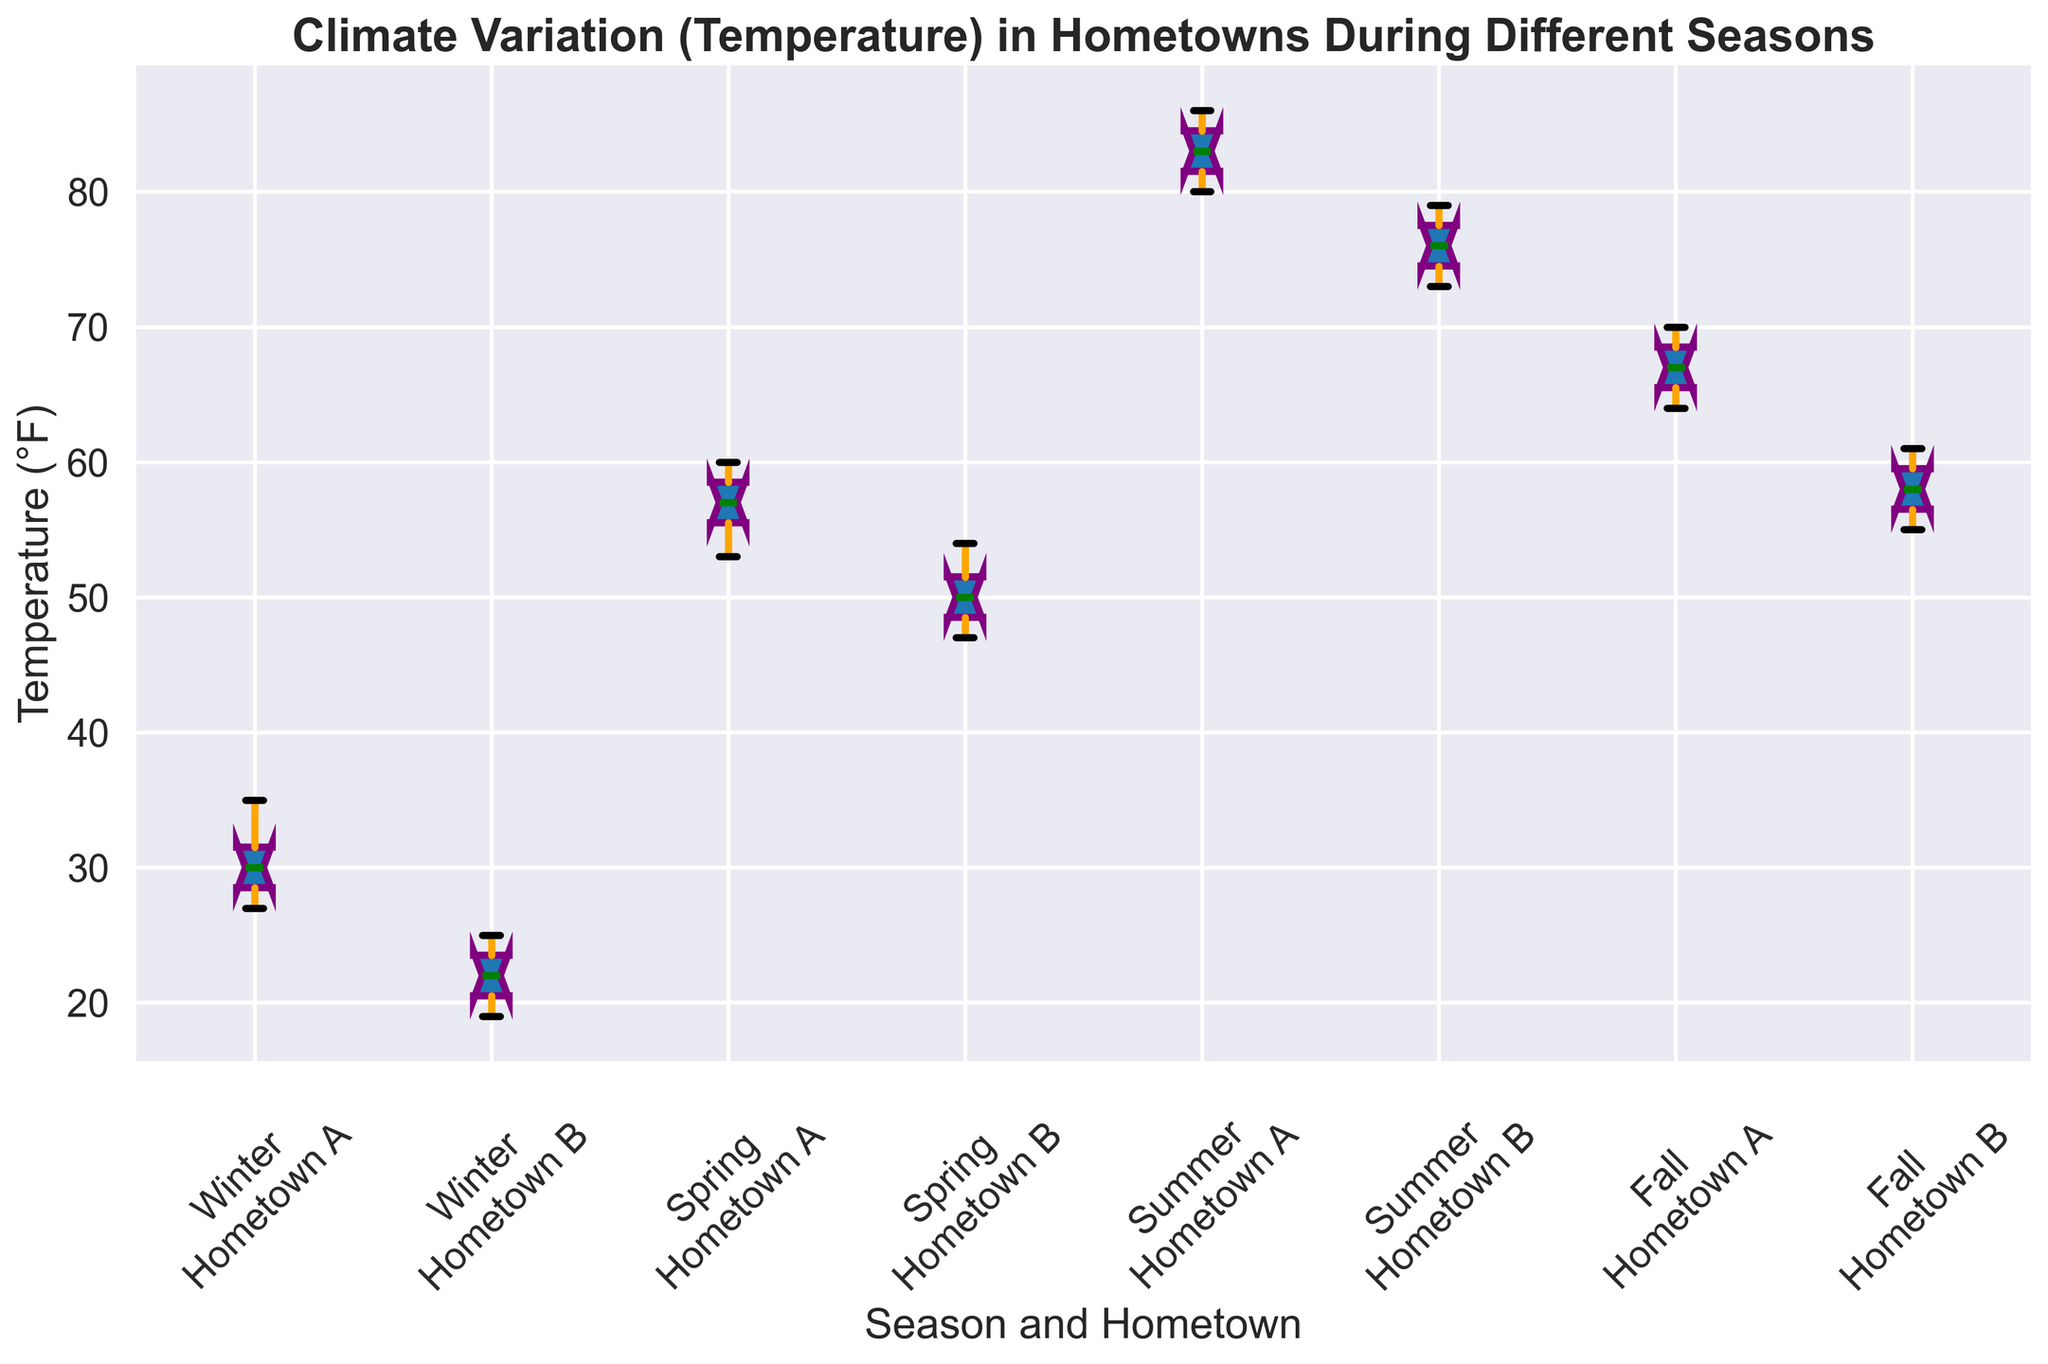What is the median temperature for Hometown A in Winter? Look at the box plot for Winter under Hometown A. The median is represented by the green line inside the box.
Answer: 30.5°F Which season shows the highest median temperature for Hometown B? Compare the median lines (green lines inside the boxes) for all the seasons under Hometown B. Identify which one is the highest.
Answer: Summer How does the temperature variation in Hometown A during Summer compare to Winter? Compare the length of the boxes (representing the interquartile range) for Summer and Winter under Hometown A to see which has larger variation, also consider the whiskers' length.
Answer: Summer has larger variation What is the interquartile range (IQR) for Hometown B in Fall? The IQR is the length of the box. Measure the distance on the y-axis between the bottom and top of the box for Fall under Hometown B.
Answer: 4°F In which season does Hometown B have the smallest temperature range? Look at the total length (box plus whiskers) for each season under Hometown B and find the smallest one.
Answer: Fall Is the median temperature higher in Spring or Summer for Hometown A? Compare the green lines inside the boxes for Spring and Summer under Hometown A to see which one is higher.
Answer: Summer How many degrees higher is the median temperature in Summer compared to Winter for Hometown A? Subtract the median temperature in Winter from the median temperature in Summer for Hometown A by looking at the green lines.
Answer: 52°F Which season has the greatest temperature variation for Hometown B? Look for the season with the largest spread (length of the box plus whiskers) under Hometown B to determine the greatest variation.
Answer: Summer Compare the temperature distributions between Hometown A and Hometown B in Spring. Look at the boxes and whiskers for Spring under both Hometown A and Hometown B to compare their centers, spreads, and overall ranges.
Answer: Hometown A is higher with less variation During which season do Hometown A and Hometown B have the closest median temperatures? Find the season where the green lines inside the boxes for Hometown A and Hometown B are closest to each other.
Answer: Fall 